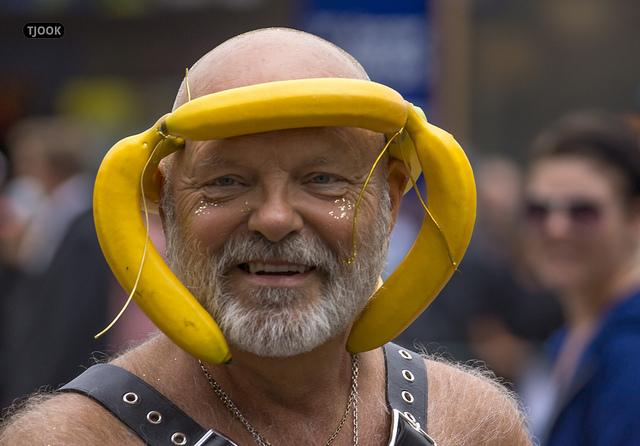If the man eats what is around his head what vitamin will he get? potassium 